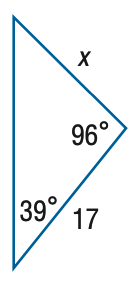Question: Find x. Round side measure to the nearest tenth.
Choices:
A. 10.8
B. 15.1
C. 19.1
D. 26.9
Answer with the letter. Answer: B 